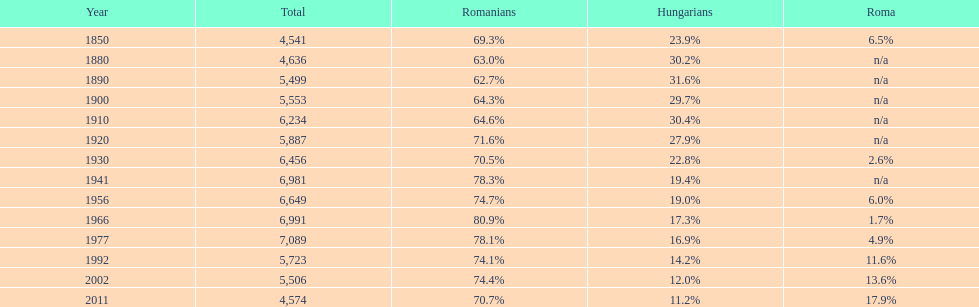Which year had the top percentage in romanian population? 1966. 